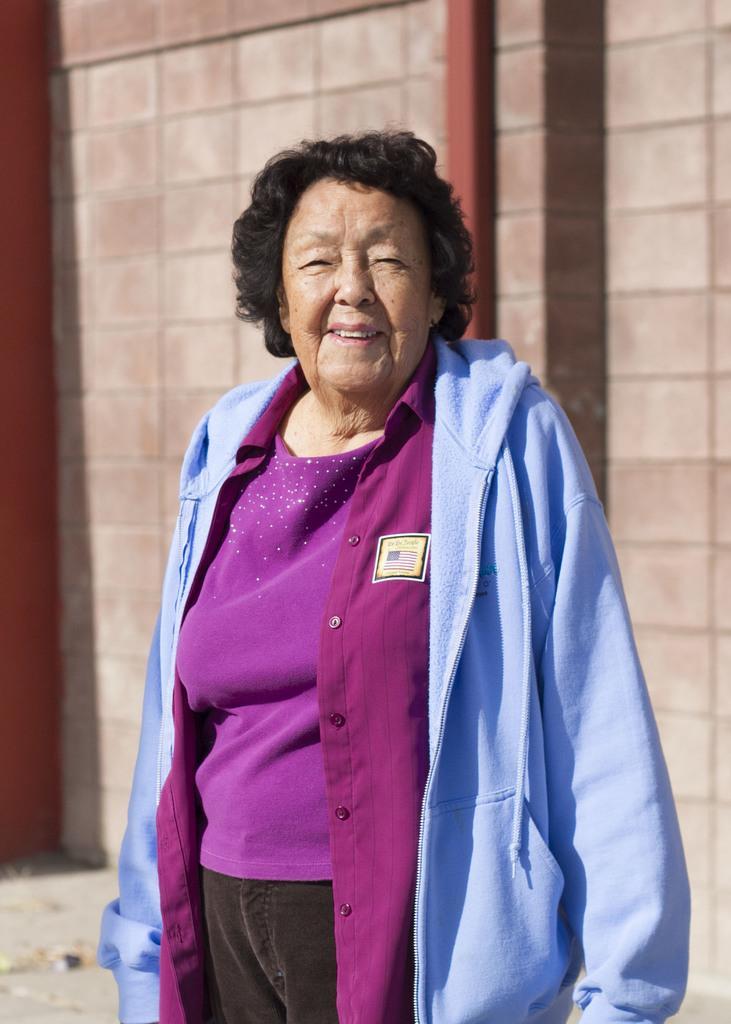Can you describe this image briefly? In this image I can see a woman is standing and smiling. The woman is wearing a blue color hoodie. In the background I can see a wall. 